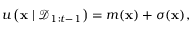<formula> <loc_0><loc_0><loc_500><loc_500>u \left ( x | \mathcal { D } _ { 1 \colon t - 1 } \right ) = m ( x ) + \sigma ( x ) ,</formula> 